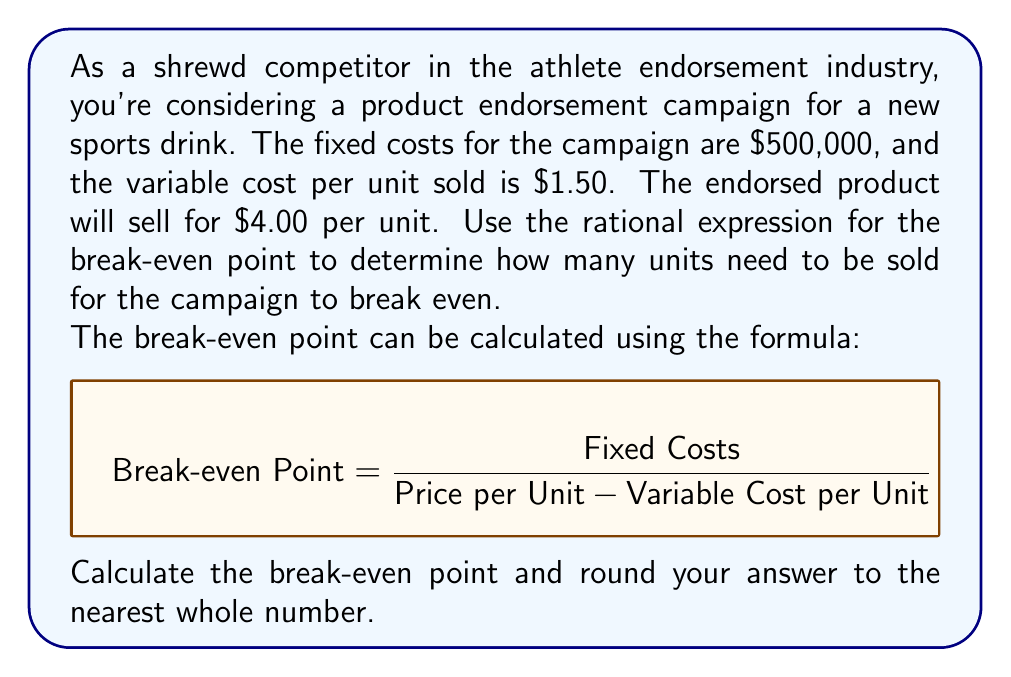Help me with this question. Let's break this down step-by-step:

1) We are given:
   - Fixed Costs (FC) = $500,000
   - Variable Cost per Unit (VC) = $1.50
   - Price per Unit (P) = $4.00

2) We'll use the break-even formula:

   $$ \text{Break-even Point} = \frac{\text{Fixed Costs}}{\text{Price per Unit} - \text{Variable Cost per Unit}} $$

3) Let's substitute our values:

   $$ \text{Break-even Point} = \frac{500,000}{4.00 - 1.50} $$

4) Simplify the denominator:

   $$ \text{Break-even Point} = \frac{500,000}{2.50} $$

5) Divide:

   $$ \text{Break-even Point} = 200,000 $$

6) Since we can't sell a fraction of a unit, we round to the nearest whole number.

Therefore, the campaign needs to sell 200,000 units to break even.
Answer: 200,000 units 